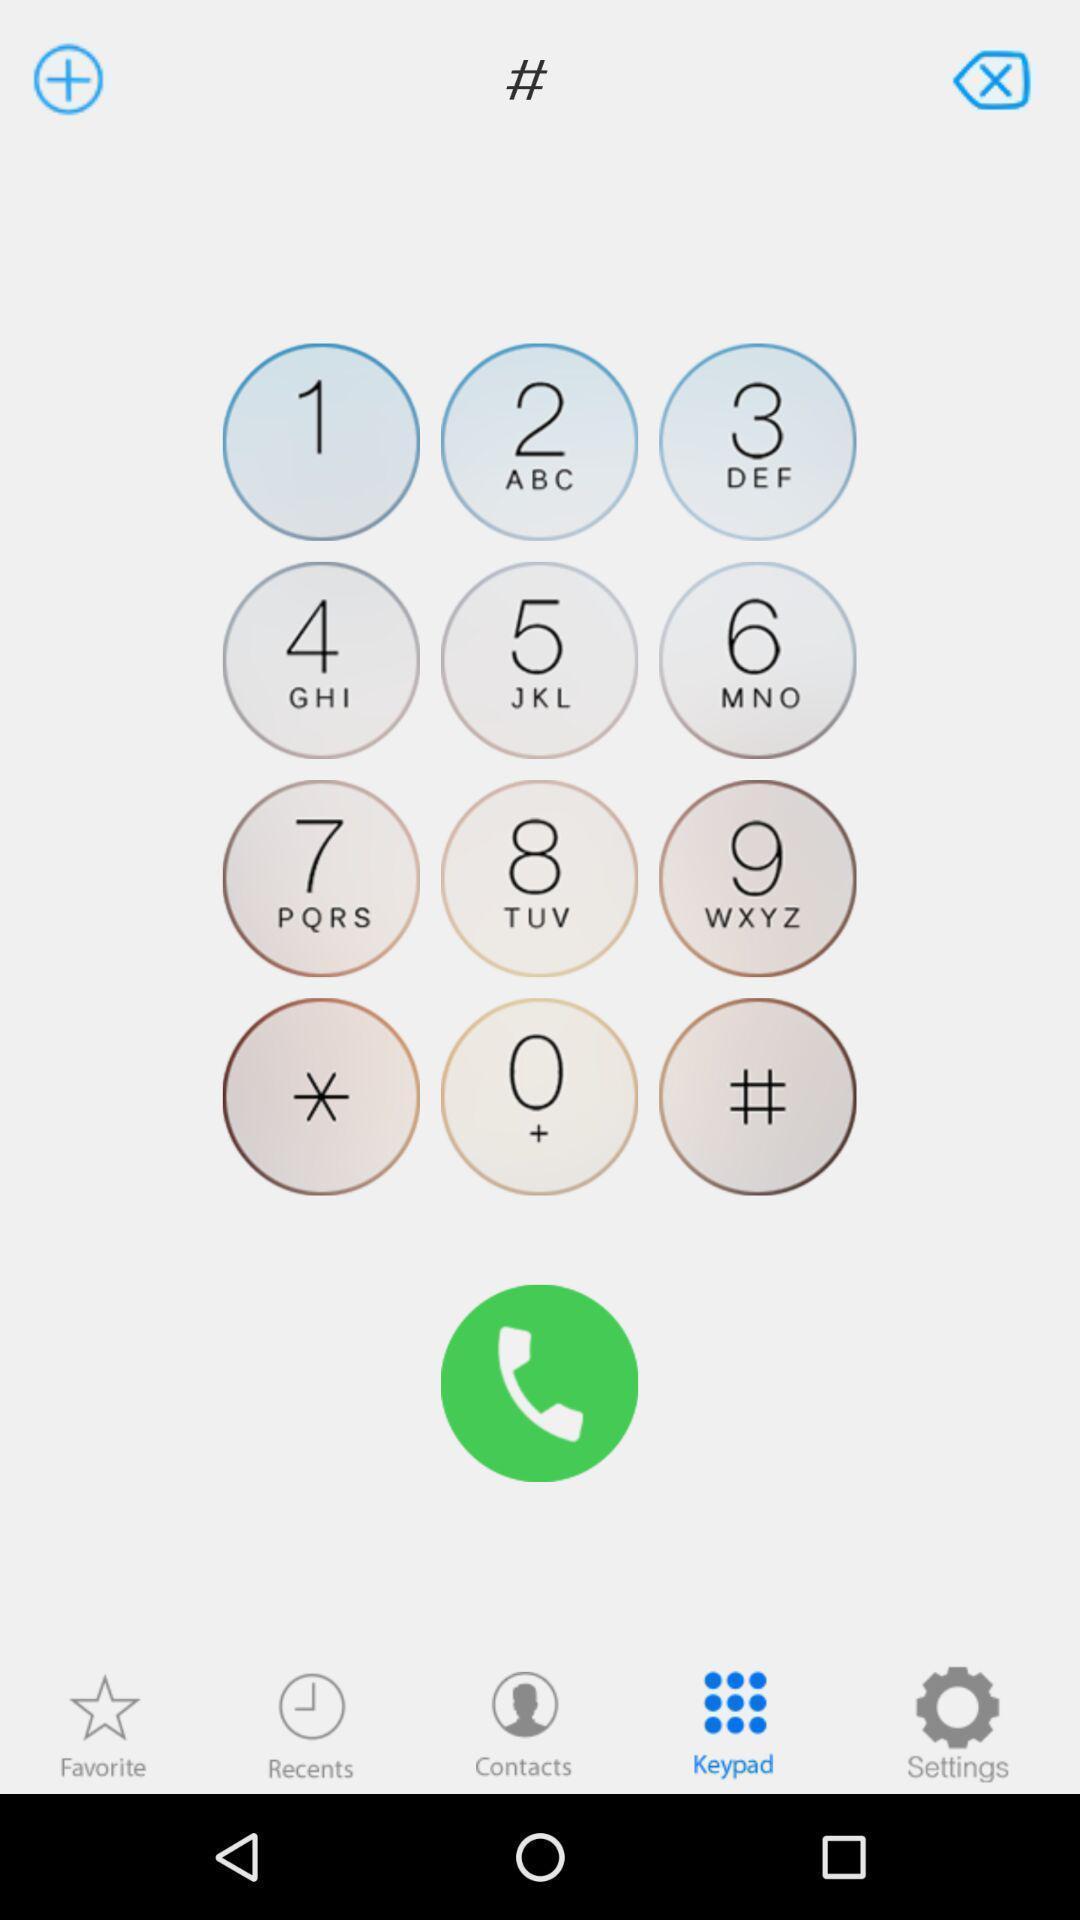What is the overall content of this screenshot? Page of a calling application. 